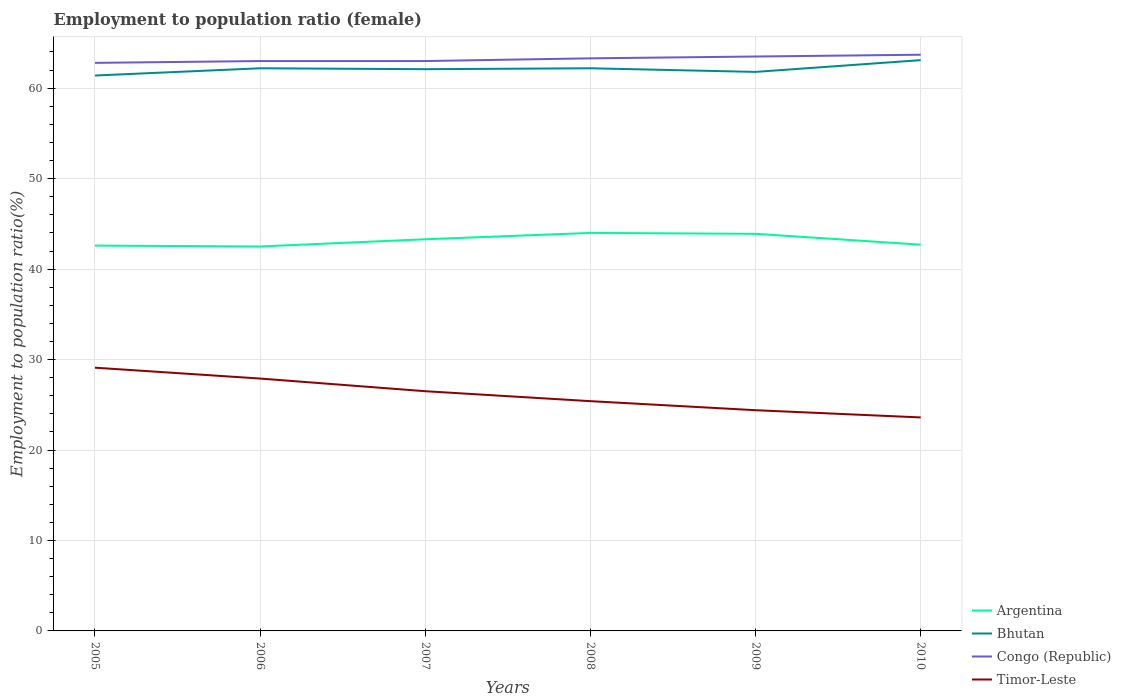Across all years, what is the maximum employment to population ratio in Timor-Leste?
Keep it short and to the point. 23.6. What is the total employment to population ratio in Bhutan in the graph?
Offer a very short reply. 0.4. How many lines are there?
Ensure brevity in your answer.  4. How many years are there in the graph?
Offer a very short reply. 6. Does the graph contain grids?
Your answer should be very brief. Yes. Where does the legend appear in the graph?
Your answer should be compact. Bottom right. How are the legend labels stacked?
Your answer should be very brief. Vertical. What is the title of the graph?
Keep it short and to the point. Employment to population ratio (female). Does "Hong Kong" appear as one of the legend labels in the graph?
Make the answer very short. No. What is the label or title of the X-axis?
Provide a short and direct response. Years. What is the Employment to population ratio(%) in Argentina in 2005?
Ensure brevity in your answer.  42.6. What is the Employment to population ratio(%) of Bhutan in 2005?
Offer a very short reply. 61.4. What is the Employment to population ratio(%) in Congo (Republic) in 2005?
Provide a short and direct response. 62.8. What is the Employment to population ratio(%) of Timor-Leste in 2005?
Give a very brief answer. 29.1. What is the Employment to population ratio(%) of Argentina in 2006?
Ensure brevity in your answer.  42.5. What is the Employment to population ratio(%) of Bhutan in 2006?
Offer a terse response. 62.2. What is the Employment to population ratio(%) in Timor-Leste in 2006?
Offer a very short reply. 27.9. What is the Employment to population ratio(%) of Argentina in 2007?
Offer a very short reply. 43.3. What is the Employment to population ratio(%) of Bhutan in 2007?
Ensure brevity in your answer.  62.1. What is the Employment to population ratio(%) of Bhutan in 2008?
Your answer should be compact. 62.2. What is the Employment to population ratio(%) of Congo (Republic) in 2008?
Your answer should be compact. 63.3. What is the Employment to population ratio(%) of Timor-Leste in 2008?
Make the answer very short. 25.4. What is the Employment to population ratio(%) in Argentina in 2009?
Offer a very short reply. 43.9. What is the Employment to population ratio(%) of Bhutan in 2009?
Offer a terse response. 61.8. What is the Employment to population ratio(%) of Congo (Republic) in 2009?
Give a very brief answer. 63.5. What is the Employment to population ratio(%) in Timor-Leste in 2009?
Provide a short and direct response. 24.4. What is the Employment to population ratio(%) in Argentina in 2010?
Give a very brief answer. 42.7. What is the Employment to population ratio(%) in Bhutan in 2010?
Give a very brief answer. 63.1. What is the Employment to population ratio(%) in Congo (Republic) in 2010?
Your response must be concise. 63.7. What is the Employment to population ratio(%) in Timor-Leste in 2010?
Provide a short and direct response. 23.6. Across all years, what is the maximum Employment to population ratio(%) of Bhutan?
Your response must be concise. 63.1. Across all years, what is the maximum Employment to population ratio(%) of Congo (Republic)?
Give a very brief answer. 63.7. Across all years, what is the maximum Employment to population ratio(%) in Timor-Leste?
Your answer should be very brief. 29.1. Across all years, what is the minimum Employment to population ratio(%) in Argentina?
Give a very brief answer. 42.5. Across all years, what is the minimum Employment to population ratio(%) of Bhutan?
Ensure brevity in your answer.  61.4. Across all years, what is the minimum Employment to population ratio(%) of Congo (Republic)?
Ensure brevity in your answer.  62.8. Across all years, what is the minimum Employment to population ratio(%) of Timor-Leste?
Provide a succinct answer. 23.6. What is the total Employment to population ratio(%) of Argentina in the graph?
Give a very brief answer. 259. What is the total Employment to population ratio(%) in Bhutan in the graph?
Offer a very short reply. 372.8. What is the total Employment to population ratio(%) of Congo (Republic) in the graph?
Give a very brief answer. 379.3. What is the total Employment to population ratio(%) in Timor-Leste in the graph?
Provide a succinct answer. 156.9. What is the difference between the Employment to population ratio(%) in Argentina in 2005 and that in 2006?
Make the answer very short. 0.1. What is the difference between the Employment to population ratio(%) in Bhutan in 2005 and that in 2006?
Offer a very short reply. -0.8. What is the difference between the Employment to population ratio(%) in Bhutan in 2005 and that in 2007?
Provide a succinct answer. -0.7. What is the difference between the Employment to population ratio(%) in Congo (Republic) in 2005 and that in 2007?
Your response must be concise. -0.2. What is the difference between the Employment to population ratio(%) in Bhutan in 2005 and that in 2008?
Keep it short and to the point. -0.8. What is the difference between the Employment to population ratio(%) in Congo (Republic) in 2005 and that in 2008?
Keep it short and to the point. -0.5. What is the difference between the Employment to population ratio(%) of Timor-Leste in 2005 and that in 2008?
Make the answer very short. 3.7. What is the difference between the Employment to population ratio(%) in Argentina in 2005 and that in 2009?
Make the answer very short. -1.3. What is the difference between the Employment to population ratio(%) in Bhutan in 2005 and that in 2009?
Offer a terse response. -0.4. What is the difference between the Employment to population ratio(%) in Congo (Republic) in 2005 and that in 2009?
Your answer should be compact. -0.7. What is the difference between the Employment to population ratio(%) in Timor-Leste in 2005 and that in 2009?
Offer a terse response. 4.7. What is the difference between the Employment to population ratio(%) of Bhutan in 2005 and that in 2010?
Offer a terse response. -1.7. What is the difference between the Employment to population ratio(%) of Timor-Leste in 2005 and that in 2010?
Give a very brief answer. 5.5. What is the difference between the Employment to population ratio(%) in Argentina in 2006 and that in 2008?
Your answer should be very brief. -1.5. What is the difference between the Employment to population ratio(%) of Timor-Leste in 2006 and that in 2008?
Your answer should be compact. 2.5. What is the difference between the Employment to population ratio(%) in Bhutan in 2006 and that in 2009?
Make the answer very short. 0.4. What is the difference between the Employment to population ratio(%) in Congo (Republic) in 2006 and that in 2009?
Your answer should be compact. -0.5. What is the difference between the Employment to population ratio(%) of Timor-Leste in 2006 and that in 2009?
Offer a terse response. 3.5. What is the difference between the Employment to population ratio(%) in Congo (Republic) in 2006 and that in 2010?
Offer a terse response. -0.7. What is the difference between the Employment to population ratio(%) of Argentina in 2007 and that in 2008?
Keep it short and to the point. -0.7. What is the difference between the Employment to population ratio(%) in Bhutan in 2007 and that in 2008?
Make the answer very short. -0.1. What is the difference between the Employment to population ratio(%) in Congo (Republic) in 2007 and that in 2008?
Make the answer very short. -0.3. What is the difference between the Employment to population ratio(%) of Bhutan in 2007 and that in 2009?
Keep it short and to the point. 0.3. What is the difference between the Employment to population ratio(%) of Timor-Leste in 2007 and that in 2009?
Provide a succinct answer. 2.1. What is the difference between the Employment to population ratio(%) in Bhutan in 2007 and that in 2010?
Keep it short and to the point. -1. What is the difference between the Employment to population ratio(%) of Bhutan in 2008 and that in 2009?
Your response must be concise. 0.4. What is the difference between the Employment to population ratio(%) in Argentina in 2008 and that in 2010?
Offer a very short reply. 1.3. What is the difference between the Employment to population ratio(%) of Congo (Republic) in 2008 and that in 2010?
Provide a succinct answer. -0.4. What is the difference between the Employment to population ratio(%) of Congo (Republic) in 2009 and that in 2010?
Provide a succinct answer. -0.2. What is the difference between the Employment to population ratio(%) in Timor-Leste in 2009 and that in 2010?
Offer a very short reply. 0.8. What is the difference between the Employment to population ratio(%) of Argentina in 2005 and the Employment to population ratio(%) of Bhutan in 2006?
Your answer should be compact. -19.6. What is the difference between the Employment to population ratio(%) of Argentina in 2005 and the Employment to population ratio(%) of Congo (Republic) in 2006?
Your answer should be compact. -20.4. What is the difference between the Employment to population ratio(%) in Argentina in 2005 and the Employment to population ratio(%) in Timor-Leste in 2006?
Give a very brief answer. 14.7. What is the difference between the Employment to population ratio(%) of Bhutan in 2005 and the Employment to population ratio(%) of Timor-Leste in 2006?
Provide a succinct answer. 33.5. What is the difference between the Employment to population ratio(%) in Congo (Republic) in 2005 and the Employment to population ratio(%) in Timor-Leste in 2006?
Your answer should be very brief. 34.9. What is the difference between the Employment to population ratio(%) in Argentina in 2005 and the Employment to population ratio(%) in Bhutan in 2007?
Your response must be concise. -19.5. What is the difference between the Employment to population ratio(%) in Argentina in 2005 and the Employment to population ratio(%) in Congo (Republic) in 2007?
Keep it short and to the point. -20.4. What is the difference between the Employment to population ratio(%) of Argentina in 2005 and the Employment to population ratio(%) of Timor-Leste in 2007?
Your response must be concise. 16.1. What is the difference between the Employment to population ratio(%) of Bhutan in 2005 and the Employment to population ratio(%) of Timor-Leste in 2007?
Provide a short and direct response. 34.9. What is the difference between the Employment to population ratio(%) of Congo (Republic) in 2005 and the Employment to population ratio(%) of Timor-Leste in 2007?
Make the answer very short. 36.3. What is the difference between the Employment to population ratio(%) of Argentina in 2005 and the Employment to population ratio(%) of Bhutan in 2008?
Provide a succinct answer. -19.6. What is the difference between the Employment to population ratio(%) in Argentina in 2005 and the Employment to population ratio(%) in Congo (Republic) in 2008?
Provide a succinct answer. -20.7. What is the difference between the Employment to population ratio(%) of Bhutan in 2005 and the Employment to population ratio(%) of Timor-Leste in 2008?
Keep it short and to the point. 36. What is the difference between the Employment to population ratio(%) in Congo (Republic) in 2005 and the Employment to population ratio(%) in Timor-Leste in 2008?
Give a very brief answer. 37.4. What is the difference between the Employment to population ratio(%) in Argentina in 2005 and the Employment to population ratio(%) in Bhutan in 2009?
Offer a very short reply. -19.2. What is the difference between the Employment to population ratio(%) in Argentina in 2005 and the Employment to population ratio(%) in Congo (Republic) in 2009?
Provide a short and direct response. -20.9. What is the difference between the Employment to population ratio(%) of Bhutan in 2005 and the Employment to population ratio(%) of Congo (Republic) in 2009?
Provide a short and direct response. -2.1. What is the difference between the Employment to population ratio(%) in Bhutan in 2005 and the Employment to population ratio(%) in Timor-Leste in 2009?
Your answer should be compact. 37. What is the difference between the Employment to population ratio(%) of Congo (Republic) in 2005 and the Employment to population ratio(%) of Timor-Leste in 2009?
Provide a succinct answer. 38.4. What is the difference between the Employment to population ratio(%) in Argentina in 2005 and the Employment to population ratio(%) in Bhutan in 2010?
Provide a short and direct response. -20.5. What is the difference between the Employment to population ratio(%) of Argentina in 2005 and the Employment to population ratio(%) of Congo (Republic) in 2010?
Your answer should be compact. -21.1. What is the difference between the Employment to population ratio(%) of Argentina in 2005 and the Employment to population ratio(%) of Timor-Leste in 2010?
Your response must be concise. 19. What is the difference between the Employment to population ratio(%) in Bhutan in 2005 and the Employment to population ratio(%) in Congo (Republic) in 2010?
Make the answer very short. -2.3. What is the difference between the Employment to population ratio(%) of Bhutan in 2005 and the Employment to population ratio(%) of Timor-Leste in 2010?
Offer a very short reply. 37.8. What is the difference between the Employment to population ratio(%) of Congo (Republic) in 2005 and the Employment to population ratio(%) of Timor-Leste in 2010?
Your answer should be very brief. 39.2. What is the difference between the Employment to population ratio(%) in Argentina in 2006 and the Employment to population ratio(%) in Bhutan in 2007?
Make the answer very short. -19.6. What is the difference between the Employment to population ratio(%) in Argentina in 2006 and the Employment to population ratio(%) in Congo (Republic) in 2007?
Provide a succinct answer. -20.5. What is the difference between the Employment to population ratio(%) of Bhutan in 2006 and the Employment to population ratio(%) of Congo (Republic) in 2007?
Offer a very short reply. -0.8. What is the difference between the Employment to population ratio(%) in Bhutan in 2006 and the Employment to population ratio(%) in Timor-Leste in 2007?
Your response must be concise. 35.7. What is the difference between the Employment to population ratio(%) of Congo (Republic) in 2006 and the Employment to population ratio(%) of Timor-Leste in 2007?
Your answer should be very brief. 36.5. What is the difference between the Employment to population ratio(%) in Argentina in 2006 and the Employment to population ratio(%) in Bhutan in 2008?
Provide a short and direct response. -19.7. What is the difference between the Employment to population ratio(%) in Argentina in 2006 and the Employment to population ratio(%) in Congo (Republic) in 2008?
Your answer should be compact. -20.8. What is the difference between the Employment to population ratio(%) in Argentina in 2006 and the Employment to population ratio(%) in Timor-Leste in 2008?
Your answer should be very brief. 17.1. What is the difference between the Employment to population ratio(%) of Bhutan in 2006 and the Employment to population ratio(%) of Congo (Republic) in 2008?
Your answer should be compact. -1.1. What is the difference between the Employment to population ratio(%) in Bhutan in 2006 and the Employment to population ratio(%) in Timor-Leste in 2008?
Make the answer very short. 36.8. What is the difference between the Employment to population ratio(%) in Congo (Republic) in 2006 and the Employment to population ratio(%) in Timor-Leste in 2008?
Keep it short and to the point. 37.6. What is the difference between the Employment to population ratio(%) in Argentina in 2006 and the Employment to population ratio(%) in Bhutan in 2009?
Ensure brevity in your answer.  -19.3. What is the difference between the Employment to population ratio(%) in Argentina in 2006 and the Employment to population ratio(%) in Timor-Leste in 2009?
Ensure brevity in your answer.  18.1. What is the difference between the Employment to population ratio(%) in Bhutan in 2006 and the Employment to population ratio(%) in Congo (Republic) in 2009?
Offer a terse response. -1.3. What is the difference between the Employment to population ratio(%) in Bhutan in 2006 and the Employment to population ratio(%) in Timor-Leste in 2009?
Your answer should be compact. 37.8. What is the difference between the Employment to population ratio(%) in Congo (Republic) in 2006 and the Employment to population ratio(%) in Timor-Leste in 2009?
Ensure brevity in your answer.  38.6. What is the difference between the Employment to population ratio(%) in Argentina in 2006 and the Employment to population ratio(%) in Bhutan in 2010?
Ensure brevity in your answer.  -20.6. What is the difference between the Employment to population ratio(%) of Argentina in 2006 and the Employment to population ratio(%) of Congo (Republic) in 2010?
Keep it short and to the point. -21.2. What is the difference between the Employment to population ratio(%) of Argentina in 2006 and the Employment to population ratio(%) of Timor-Leste in 2010?
Your response must be concise. 18.9. What is the difference between the Employment to population ratio(%) in Bhutan in 2006 and the Employment to population ratio(%) in Timor-Leste in 2010?
Your answer should be very brief. 38.6. What is the difference between the Employment to population ratio(%) in Congo (Republic) in 2006 and the Employment to population ratio(%) in Timor-Leste in 2010?
Offer a very short reply. 39.4. What is the difference between the Employment to population ratio(%) of Argentina in 2007 and the Employment to population ratio(%) of Bhutan in 2008?
Ensure brevity in your answer.  -18.9. What is the difference between the Employment to population ratio(%) in Bhutan in 2007 and the Employment to population ratio(%) in Timor-Leste in 2008?
Ensure brevity in your answer.  36.7. What is the difference between the Employment to population ratio(%) of Congo (Republic) in 2007 and the Employment to population ratio(%) of Timor-Leste in 2008?
Provide a succinct answer. 37.6. What is the difference between the Employment to population ratio(%) in Argentina in 2007 and the Employment to population ratio(%) in Bhutan in 2009?
Your answer should be compact. -18.5. What is the difference between the Employment to population ratio(%) of Argentina in 2007 and the Employment to population ratio(%) of Congo (Republic) in 2009?
Provide a succinct answer. -20.2. What is the difference between the Employment to population ratio(%) in Bhutan in 2007 and the Employment to population ratio(%) in Congo (Republic) in 2009?
Provide a short and direct response. -1.4. What is the difference between the Employment to population ratio(%) of Bhutan in 2007 and the Employment to population ratio(%) of Timor-Leste in 2009?
Ensure brevity in your answer.  37.7. What is the difference between the Employment to population ratio(%) in Congo (Republic) in 2007 and the Employment to population ratio(%) in Timor-Leste in 2009?
Your answer should be compact. 38.6. What is the difference between the Employment to population ratio(%) in Argentina in 2007 and the Employment to population ratio(%) in Bhutan in 2010?
Your answer should be compact. -19.8. What is the difference between the Employment to population ratio(%) of Argentina in 2007 and the Employment to population ratio(%) of Congo (Republic) in 2010?
Your response must be concise. -20.4. What is the difference between the Employment to population ratio(%) of Bhutan in 2007 and the Employment to population ratio(%) of Congo (Republic) in 2010?
Provide a succinct answer. -1.6. What is the difference between the Employment to population ratio(%) in Bhutan in 2007 and the Employment to population ratio(%) in Timor-Leste in 2010?
Provide a succinct answer. 38.5. What is the difference between the Employment to population ratio(%) of Congo (Republic) in 2007 and the Employment to population ratio(%) of Timor-Leste in 2010?
Offer a very short reply. 39.4. What is the difference between the Employment to population ratio(%) in Argentina in 2008 and the Employment to population ratio(%) in Bhutan in 2009?
Make the answer very short. -17.8. What is the difference between the Employment to population ratio(%) of Argentina in 2008 and the Employment to population ratio(%) of Congo (Republic) in 2009?
Provide a short and direct response. -19.5. What is the difference between the Employment to population ratio(%) of Argentina in 2008 and the Employment to population ratio(%) of Timor-Leste in 2009?
Make the answer very short. 19.6. What is the difference between the Employment to population ratio(%) of Bhutan in 2008 and the Employment to population ratio(%) of Congo (Republic) in 2009?
Offer a terse response. -1.3. What is the difference between the Employment to population ratio(%) of Bhutan in 2008 and the Employment to population ratio(%) of Timor-Leste in 2009?
Your answer should be compact. 37.8. What is the difference between the Employment to population ratio(%) of Congo (Republic) in 2008 and the Employment to population ratio(%) of Timor-Leste in 2009?
Give a very brief answer. 38.9. What is the difference between the Employment to population ratio(%) in Argentina in 2008 and the Employment to population ratio(%) in Bhutan in 2010?
Offer a terse response. -19.1. What is the difference between the Employment to population ratio(%) in Argentina in 2008 and the Employment to population ratio(%) in Congo (Republic) in 2010?
Offer a terse response. -19.7. What is the difference between the Employment to population ratio(%) in Argentina in 2008 and the Employment to population ratio(%) in Timor-Leste in 2010?
Give a very brief answer. 20.4. What is the difference between the Employment to population ratio(%) in Bhutan in 2008 and the Employment to population ratio(%) in Congo (Republic) in 2010?
Your answer should be very brief. -1.5. What is the difference between the Employment to population ratio(%) of Bhutan in 2008 and the Employment to population ratio(%) of Timor-Leste in 2010?
Provide a short and direct response. 38.6. What is the difference between the Employment to population ratio(%) of Congo (Republic) in 2008 and the Employment to population ratio(%) of Timor-Leste in 2010?
Offer a very short reply. 39.7. What is the difference between the Employment to population ratio(%) in Argentina in 2009 and the Employment to population ratio(%) in Bhutan in 2010?
Make the answer very short. -19.2. What is the difference between the Employment to population ratio(%) of Argentina in 2009 and the Employment to population ratio(%) of Congo (Republic) in 2010?
Make the answer very short. -19.8. What is the difference between the Employment to population ratio(%) in Argentina in 2009 and the Employment to population ratio(%) in Timor-Leste in 2010?
Your answer should be compact. 20.3. What is the difference between the Employment to population ratio(%) in Bhutan in 2009 and the Employment to population ratio(%) in Timor-Leste in 2010?
Give a very brief answer. 38.2. What is the difference between the Employment to population ratio(%) of Congo (Republic) in 2009 and the Employment to population ratio(%) of Timor-Leste in 2010?
Your answer should be compact. 39.9. What is the average Employment to population ratio(%) of Argentina per year?
Offer a terse response. 43.17. What is the average Employment to population ratio(%) in Bhutan per year?
Offer a very short reply. 62.13. What is the average Employment to population ratio(%) in Congo (Republic) per year?
Offer a very short reply. 63.22. What is the average Employment to population ratio(%) of Timor-Leste per year?
Your answer should be very brief. 26.15. In the year 2005, what is the difference between the Employment to population ratio(%) in Argentina and Employment to population ratio(%) in Bhutan?
Provide a short and direct response. -18.8. In the year 2005, what is the difference between the Employment to population ratio(%) of Argentina and Employment to population ratio(%) of Congo (Republic)?
Provide a short and direct response. -20.2. In the year 2005, what is the difference between the Employment to population ratio(%) in Argentina and Employment to population ratio(%) in Timor-Leste?
Your response must be concise. 13.5. In the year 2005, what is the difference between the Employment to population ratio(%) of Bhutan and Employment to population ratio(%) of Congo (Republic)?
Offer a terse response. -1.4. In the year 2005, what is the difference between the Employment to population ratio(%) in Bhutan and Employment to population ratio(%) in Timor-Leste?
Your answer should be compact. 32.3. In the year 2005, what is the difference between the Employment to population ratio(%) of Congo (Republic) and Employment to population ratio(%) of Timor-Leste?
Your answer should be very brief. 33.7. In the year 2006, what is the difference between the Employment to population ratio(%) in Argentina and Employment to population ratio(%) in Bhutan?
Your answer should be compact. -19.7. In the year 2006, what is the difference between the Employment to population ratio(%) in Argentina and Employment to population ratio(%) in Congo (Republic)?
Your response must be concise. -20.5. In the year 2006, what is the difference between the Employment to population ratio(%) of Bhutan and Employment to population ratio(%) of Congo (Republic)?
Ensure brevity in your answer.  -0.8. In the year 2006, what is the difference between the Employment to population ratio(%) in Bhutan and Employment to population ratio(%) in Timor-Leste?
Provide a short and direct response. 34.3. In the year 2006, what is the difference between the Employment to population ratio(%) in Congo (Republic) and Employment to population ratio(%) in Timor-Leste?
Offer a terse response. 35.1. In the year 2007, what is the difference between the Employment to population ratio(%) in Argentina and Employment to population ratio(%) in Bhutan?
Your response must be concise. -18.8. In the year 2007, what is the difference between the Employment to population ratio(%) of Argentina and Employment to population ratio(%) of Congo (Republic)?
Provide a short and direct response. -19.7. In the year 2007, what is the difference between the Employment to population ratio(%) in Argentina and Employment to population ratio(%) in Timor-Leste?
Make the answer very short. 16.8. In the year 2007, what is the difference between the Employment to population ratio(%) of Bhutan and Employment to population ratio(%) of Congo (Republic)?
Make the answer very short. -0.9. In the year 2007, what is the difference between the Employment to population ratio(%) in Bhutan and Employment to population ratio(%) in Timor-Leste?
Make the answer very short. 35.6. In the year 2007, what is the difference between the Employment to population ratio(%) in Congo (Republic) and Employment to population ratio(%) in Timor-Leste?
Offer a very short reply. 36.5. In the year 2008, what is the difference between the Employment to population ratio(%) of Argentina and Employment to population ratio(%) of Bhutan?
Keep it short and to the point. -18.2. In the year 2008, what is the difference between the Employment to population ratio(%) in Argentina and Employment to population ratio(%) in Congo (Republic)?
Provide a short and direct response. -19.3. In the year 2008, what is the difference between the Employment to population ratio(%) in Argentina and Employment to population ratio(%) in Timor-Leste?
Offer a terse response. 18.6. In the year 2008, what is the difference between the Employment to population ratio(%) of Bhutan and Employment to population ratio(%) of Congo (Republic)?
Provide a short and direct response. -1.1. In the year 2008, what is the difference between the Employment to population ratio(%) of Bhutan and Employment to population ratio(%) of Timor-Leste?
Your answer should be very brief. 36.8. In the year 2008, what is the difference between the Employment to population ratio(%) of Congo (Republic) and Employment to population ratio(%) of Timor-Leste?
Offer a very short reply. 37.9. In the year 2009, what is the difference between the Employment to population ratio(%) in Argentina and Employment to population ratio(%) in Bhutan?
Your answer should be compact. -17.9. In the year 2009, what is the difference between the Employment to population ratio(%) of Argentina and Employment to population ratio(%) of Congo (Republic)?
Your answer should be compact. -19.6. In the year 2009, what is the difference between the Employment to population ratio(%) of Argentina and Employment to population ratio(%) of Timor-Leste?
Ensure brevity in your answer.  19.5. In the year 2009, what is the difference between the Employment to population ratio(%) in Bhutan and Employment to population ratio(%) in Congo (Republic)?
Offer a terse response. -1.7. In the year 2009, what is the difference between the Employment to population ratio(%) in Bhutan and Employment to population ratio(%) in Timor-Leste?
Provide a short and direct response. 37.4. In the year 2009, what is the difference between the Employment to population ratio(%) in Congo (Republic) and Employment to population ratio(%) in Timor-Leste?
Keep it short and to the point. 39.1. In the year 2010, what is the difference between the Employment to population ratio(%) in Argentina and Employment to population ratio(%) in Bhutan?
Give a very brief answer. -20.4. In the year 2010, what is the difference between the Employment to population ratio(%) in Argentina and Employment to population ratio(%) in Congo (Republic)?
Offer a terse response. -21. In the year 2010, what is the difference between the Employment to population ratio(%) of Bhutan and Employment to population ratio(%) of Timor-Leste?
Offer a terse response. 39.5. In the year 2010, what is the difference between the Employment to population ratio(%) of Congo (Republic) and Employment to population ratio(%) of Timor-Leste?
Keep it short and to the point. 40.1. What is the ratio of the Employment to population ratio(%) of Argentina in 2005 to that in 2006?
Your response must be concise. 1. What is the ratio of the Employment to population ratio(%) in Bhutan in 2005 to that in 2006?
Give a very brief answer. 0.99. What is the ratio of the Employment to population ratio(%) of Timor-Leste in 2005 to that in 2006?
Give a very brief answer. 1.04. What is the ratio of the Employment to population ratio(%) of Argentina in 2005 to that in 2007?
Provide a succinct answer. 0.98. What is the ratio of the Employment to population ratio(%) in Bhutan in 2005 to that in 2007?
Give a very brief answer. 0.99. What is the ratio of the Employment to population ratio(%) of Timor-Leste in 2005 to that in 2007?
Ensure brevity in your answer.  1.1. What is the ratio of the Employment to population ratio(%) of Argentina in 2005 to that in 2008?
Ensure brevity in your answer.  0.97. What is the ratio of the Employment to population ratio(%) in Bhutan in 2005 to that in 2008?
Keep it short and to the point. 0.99. What is the ratio of the Employment to population ratio(%) in Timor-Leste in 2005 to that in 2008?
Ensure brevity in your answer.  1.15. What is the ratio of the Employment to population ratio(%) in Argentina in 2005 to that in 2009?
Make the answer very short. 0.97. What is the ratio of the Employment to population ratio(%) in Bhutan in 2005 to that in 2009?
Ensure brevity in your answer.  0.99. What is the ratio of the Employment to population ratio(%) of Timor-Leste in 2005 to that in 2009?
Ensure brevity in your answer.  1.19. What is the ratio of the Employment to population ratio(%) in Argentina in 2005 to that in 2010?
Make the answer very short. 1. What is the ratio of the Employment to population ratio(%) in Bhutan in 2005 to that in 2010?
Your answer should be very brief. 0.97. What is the ratio of the Employment to population ratio(%) in Congo (Republic) in 2005 to that in 2010?
Make the answer very short. 0.99. What is the ratio of the Employment to population ratio(%) in Timor-Leste in 2005 to that in 2010?
Your answer should be very brief. 1.23. What is the ratio of the Employment to population ratio(%) in Argentina in 2006 to that in 2007?
Your answer should be very brief. 0.98. What is the ratio of the Employment to population ratio(%) in Timor-Leste in 2006 to that in 2007?
Offer a very short reply. 1.05. What is the ratio of the Employment to population ratio(%) of Argentina in 2006 to that in 2008?
Your answer should be very brief. 0.97. What is the ratio of the Employment to population ratio(%) in Congo (Republic) in 2006 to that in 2008?
Provide a succinct answer. 1. What is the ratio of the Employment to population ratio(%) of Timor-Leste in 2006 to that in 2008?
Your response must be concise. 1.1. What is the ratio of the Employment to population ratio(%) in Argentina in 2006 to that in 2009?
Provide a succinct answer. 0.97. What is the ratio of the Employment to population ratio(%) of Bhutan in 2006 to that in 2009?
Give a very brief answer. 1.01. What is the ratio of the Employment to population ratio(%) of Congo (Republic) in 2006 to that in 2009?
Your answer should be very brief. 0.99. What is the ratio of the Employment to population ratio(%) of Timor-Leste in 2006 to that in 2009?
Keep it short and to the point. 1.14. What is the ratio of the Employment to population ratio(%) of Bhutan in 2006 to that in 2010?
Offer a terse response. 0.99. What is the ratio of the Employment to population ratio(%) in Timor-Leste in 2006 to that in 2010?
Offer a terse response. 1.18. What is the ratio of the Employment to population ratio(%) in Argentina in 2007 to that in 2008?
Provide a succinct answer. 0.98. What is the ratio of the Employment to population ratio(%) of Bhutan in 2007 to that in 2008?
Offer a very short reply. 1. What is the ratio of the Employment to population ratio(%) in Congo (Republic) in 2007 to that in 2008?
Your response must be concise. 1. What is the ratio of the Employment to population ratio(%) in Timor-Leste in 2007 to that in 2008?
Offer a terse response. 1.04. What is the ratio of the Employment to population ratio(%) in Argentina in 2007 to that in 2009?
Ensure brevity in your answer.  0.99. What is the ratio of the Employment to population ratio(%) in Timor-Leste in 2007 to that in 2009?
Your answer should be compact. 1.09. What is the ratio of the Employment to population ratio(%) of Argentina in 2007 to that in 2010?
Provide a short and direct response. 1.01. What is the ratio of the Employment to population ratio(%) of Bhutan in 2007 to that in 2010?
Your response must be concise. 0.98. What is the ratio of the Employment to population ratio(%) in Timor-Leste in 2007 to that in 2010?
Give a very brief answer. 1.12. What is the ratio of the Employment to population ratio(%) in Argentina in 2008 to that in 2009?
Keep it short and to the point. 1. What is the ratio of the Employment to population ratio(%) in Bhutan in 2008 to that in 2009?
Ensure brevity in your answer.  1.01. What is the ratio of the Employment to population ratio(%) in Timor-Leste in 2008 to that in 2009?
Provide a short and direct response. 1.04. What is the ratio of the Employment to population ratio(%) of Argentina in 2008 to that in 2010?
Your response must be concise. 1.03. What is the ratio of the Employment to population ratio(%) in Bhutan in 2008 to that in 2010?
Make the answer very short. 0.99. What is the ratio of the Employment to population ratio(%) of Congo (Republic) in 2008 to that in 2010?
Make the answer very short. 0.99. What is the ratio of the Employment to population ratio(%) of Timor-Leste in 2008 to that in 2010?
Offer a very short reply. 1.08. What is the ratio of the Employment to population ratio(%) of Argentina in 2009 to that in 2010?
Keep it short and to the point. 1.03. What is the ratio of the Employment to population ratio(%) of Bhutan in 2009 to that in 2010?
Keep it short and to the point. 0.98. What is the ratio of the Employment to population ratio(%) in Timor-Leste in 2009 to that in 2010?
Make the answer very short. 1.03. What is the difference between the highest and the second highest Employment to population ratio(%) in Argentina?
Provide a short and direct response. 0.1. What is the difference between the highest and the second highest Employment to population ratio(%) in Bhutan?
Your answer should be compact. 0.9. What is the difference between the highest and the second highest Employment to population ratio(%) of Congo (Republic)?
Provide a short and direct response. 0.2. 